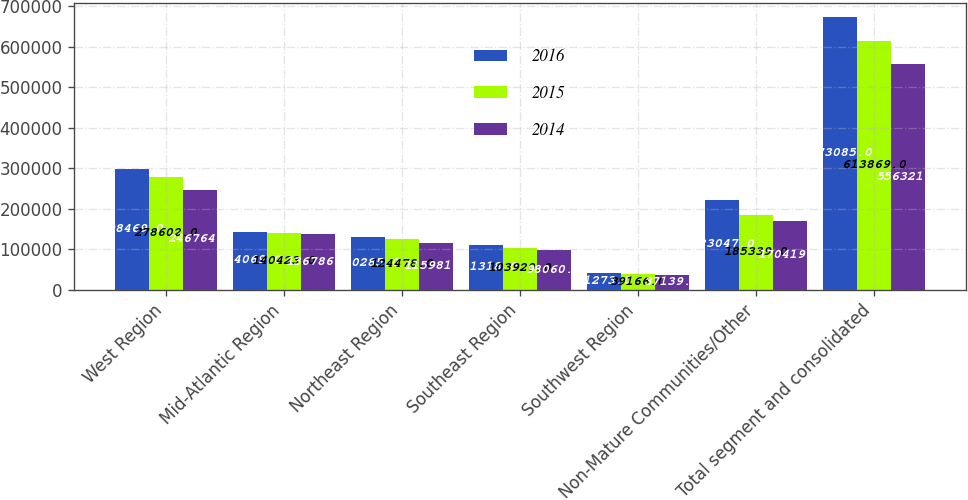<chart> <loc_0><loc_0><loc_500><loc_500><stacked_bar_chart><ecel><fcel>West Region<fcel>Mid­Atlantic Region<fcel>Northeast Region<fcel>Southeast Region<fcel>Southwest Region<fcel>Non­Mature Communities/Other<fcel>Total segment and consolidated<nl><fcel>2016<fcel>298469<fcel>144069<fcel>130285<fcel>111318<fcel>41273<fcel>223047<fcel>673085<nl><fcel>2015<fcel>278602<fcel>140423<fcel>124478<fcel>103920<fcel>39166<fcel>185339<fcel>613869<nl><fcel>2014<fcel>246764<fcel>136786<fcel>115981<fcel>98060<fcel>37139<fcel>170419<fcel>556321<nl></chart> 